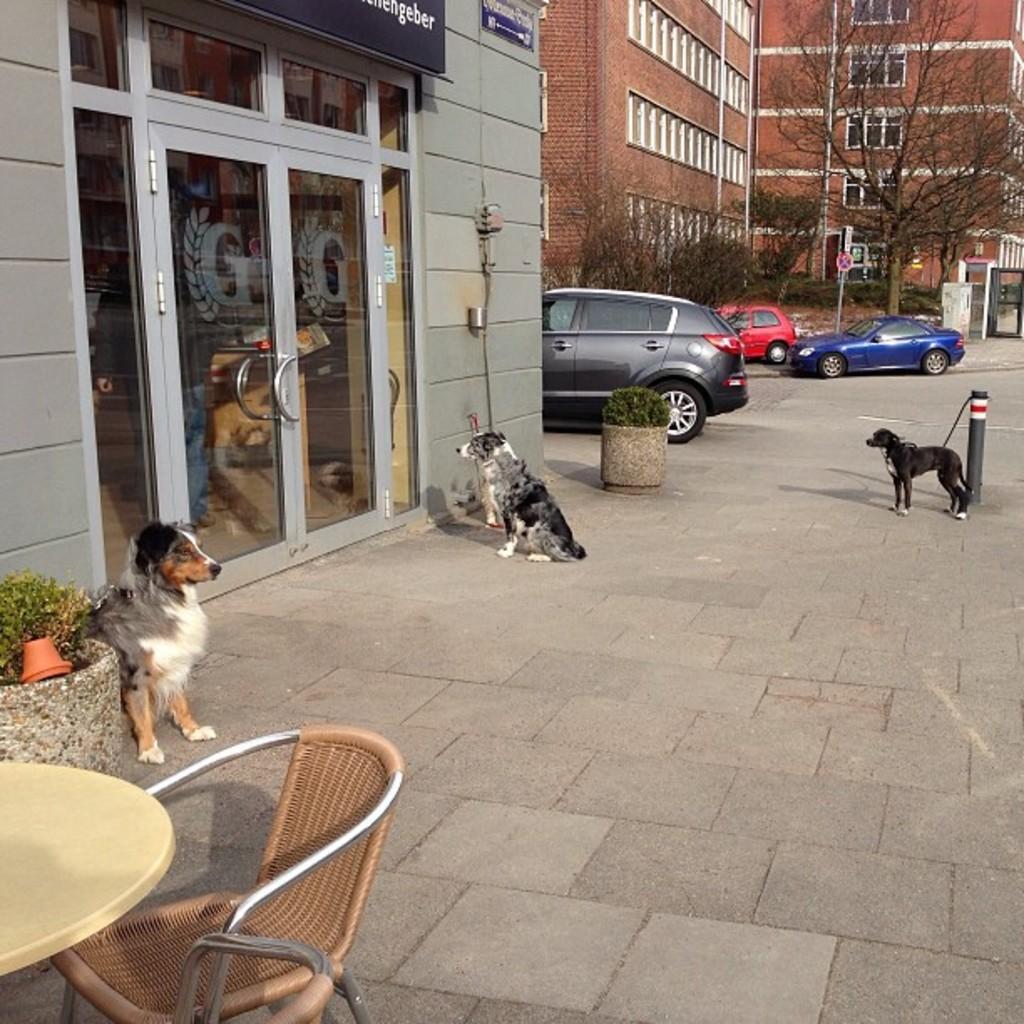In one or two sentences, can you explain what this image depicts? In this image I can see few dogs and cars on the road. To the left there is a table and a chair. In the background there are trees and the building. 